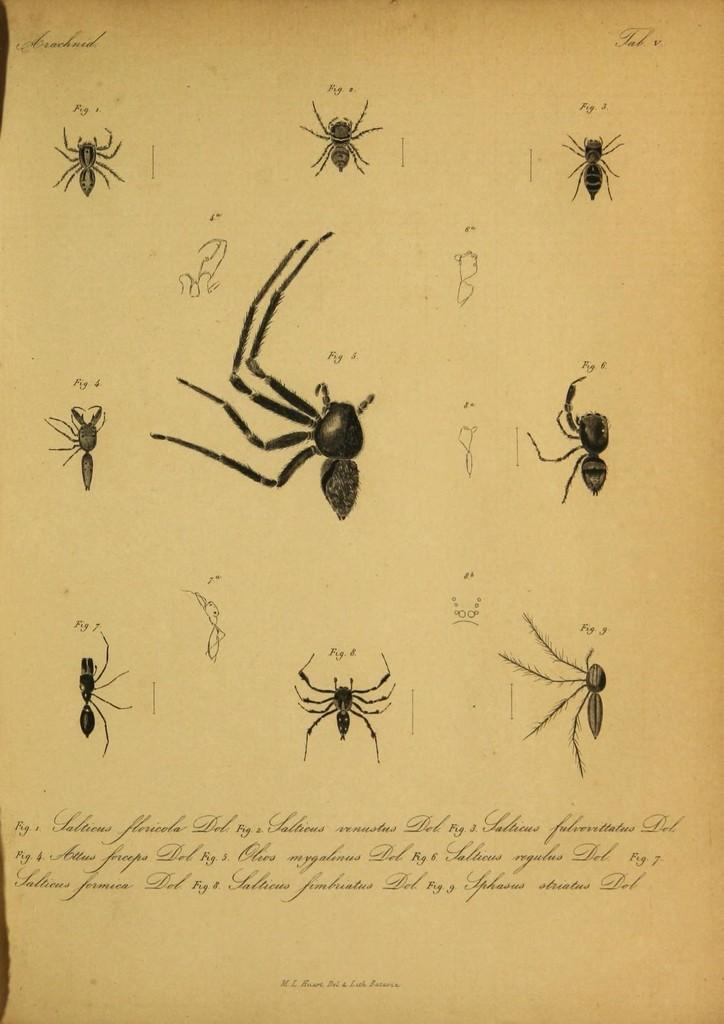What type of visual representation is the image? The image is a poster. What can be found on the poster besides text? There are pictures on the poster. What information is conveyed through the text on the poster? The text on the poster provides additional information or context. What color is the crayon used to draw the zebra on the poster? There is no crayon or zebra depicted on the poster; it features pictures and text. 